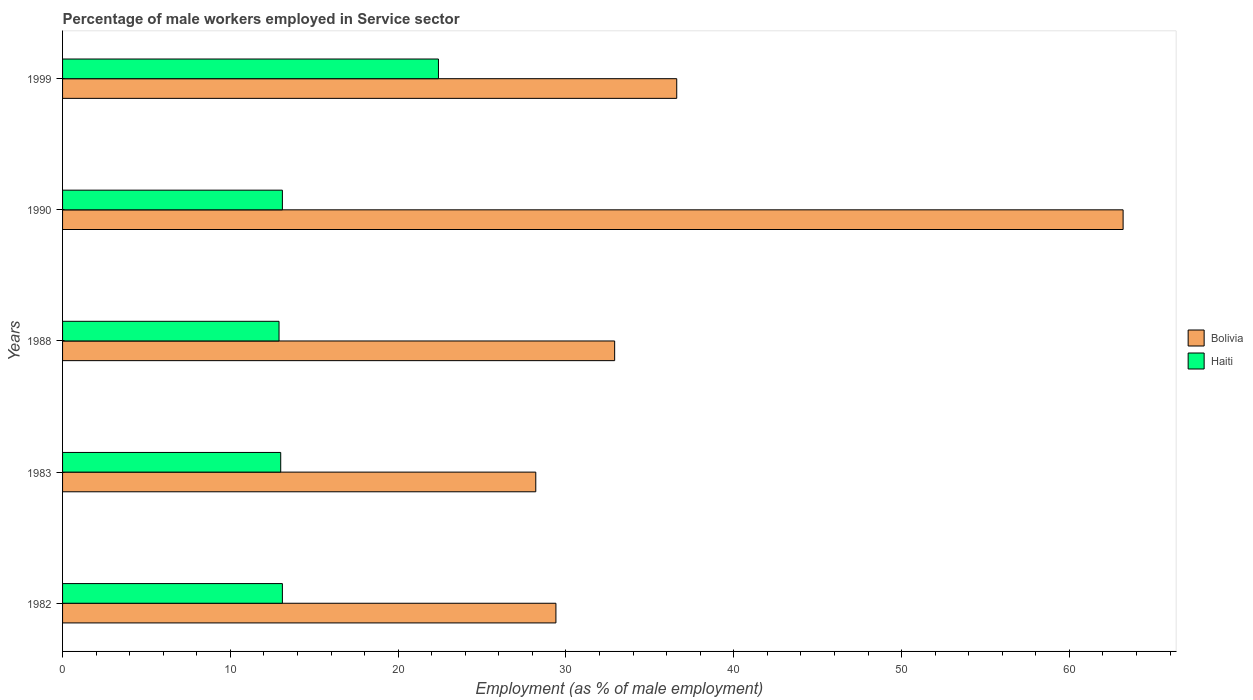How many groups of bars are there?
Keep it short and to the point. 5. Are the number of bars per tick equal to the number of legend labels?
Your response must be concise. Yes. Are the number of bars on each tick of the Y-axis equal?
Offer a very short reply. Yes. How many bars are there on the 2nd tick from the top?
Provide a succinct answer. 2. How many bars are there on the 4th tick from the bottom?
Ensure brevity in your answer.  2. What is the label of the 4th group of bars from the top?
Offer a very short reply. 1983. What is the percentage of male workers employed in Service sector in Haiti in 1988?
Give a very brief answer. 12.9. Across all years, what is the maximum percentage of male workers employed in Service sector in Bolivia?
Make the answer very short. 63.2. Across all years, what is the minimum percentage of male workers employed in Service sector in Bolivia?
Provide a succinct answer. 28.2. In which year was the percentage of male workers employed in Service sector in Bolivia maximum?
Provide a short and direct response. 1990. What is the total percentage of male workers employed in Service sector in Haiti in the graph?
Provide a short and direct response. 74.5. What is the difference between the percentage of male workers employed in Service sector in Haiti in 1990 and that in 1999?
Make the answer very short. -9.3. What is the difference between the percentage of male workers employed in Service sector in Bolivia in 1988 and the percentage of male workers employed in Service sector in Haiti in 1982?
Your answer should be compact. 19.8. In the year 1988, what is the difference between the percentage of male workers employed in Service sector in Bolivia and percentage of male workers employed in Service sector in Haiti?
Give a very brief answer. 20. In how many years, is the percentage of male workers employed in Service sector in Bolivia greater than 20 %?
Your answer should be compact. 5. What is the ratio of the percentage of male workers employed in Service sector in Haiti in 1988 to that in 1999?
Keep it short and to the point. 0.58. Is the difference between the percentage of male workers employed in Service sector in Bolivia in 1982 and 1999 greater than the difference between the percentage of male workers employed in Service sector in Haiti in 1982 and 1999?
Provide a short and direct response. Yes. What is the difference between the highest and the second highest percentage of male workers employed in Service sector in Bolivia?
Ensure brevity in your answer.  26.6. What is the difference between the highest and the lowest percentage of male workers employed in Service sector in Haiti?
Provide a short and direct response. 9.5. In how many years, is the percentage of male workers employed in Service sector in Bolivia greater than the average percentage of male workers employed in Service sector in Bolivia taken over all years?
Your response must be concise. 1. Is the sum of the percentage of male workers employed in Service sector in Bolivia in 1982 and 1983 greater than the maximum percentage of male workers employed in Service sector in Haiti across all years?
Ensure brevity in your answer.  Yes. What does the 1st bar from the top in 1982 represents?
Ensure brevity in your answer.  Haiti. What does the 1st bar from the bottom in 1982 represents?
Keep it short and to the point. Bolivia. Are all the bars in the graph horizontal?
Provide a succinct answer. Yes. How many years are there in the graph?
Provide a short and direct response. 5. Does the graph contain any zero values?
Your answer should be very brief. No. Where does the legend appear in the graph?
Your response must be concise. Center right. How are the legend labels stacked?
Provide a short and direct response. Vertical. What is the title of the graph?
Your answer should be very brief. Percentage of male workers employed in Service sector. Does "Swaziland" appear as one of the legend labels in the graph?
Offer a very short reply. No. What is the label or title of the X-axis?
Offer a very short reply. Employment (as % of male employment). What is the Employment (as % of male employment) of Bolivia in 1982?
Give a very brief answer. 29.4. What is the Employment (as % of male employment) in Haiti in 1982?
Keep it short and to the point. 13.1. What is the Employment (as % of male employment) in Bolivia in 1983?
Provide a succinct answer. 28.2. What is the Employment (as % of male employment) of Bolivia in 1988?
Your answer should be compact. 32.9. What is the Employment (as % of male employment) of Haiti in 1988?
Keep it short and to the point. 12.9. What is the Employment (as % of male employment) in Bolivia in 1990?
Your response must be concise. 63.2. What is the Employment (as % of male employment) in Haiti in 1990?
Provide a short and direct response. 13.1. What is the Employment (as % of male employment) in Bolivia in 1999?
Your answer should be compact. 36.6. What is the Employment (as % of male employment) in Haiti in 1999?
Offer a very short reply. 22.4. Across all years, what is the maximum Employment (as % of male employment) of Bolivia?
Offer a terse response. 63.2. Across all years, what is the maximum Employment (as % of male employment) in Haiti?
Offer a very short reply. 22.4. Across all years, what is the minimum Employment (as % of male employment) in Bolivia?
Your answer should be very brief. 28.2. Across all years, what is the minimum Employment (as % of male employment) in Haiti?
Your answer should be very brief. 12.9. What is the total Employment (as % of male employment) in Bolivia in the graph?
Keep it short and to the point. 190.3. What is the total Employment (as % of male employment) in Haiti in the graph?
Your answer should be compact. 74.5. What is the difference between the Employment (as % of male employment) of Haiti in 1982 and that in 1983?
Ensure brevity in your answer.  0.1. What is the difference between the Employment (as % of male employment) of Bolivia in 1982 and that in 1988?
Your response must be concise. -3.5. What is the difference between the Employment (as % of male employment) of Bolivia in 1982 and that in 1990?
Provide a short and direct response. -33.8. What is the difference between the Employment (as % of male employment) of Haiti in 1982 and that in 1990?
Provide a succinct answer. 0. What is the difference between the Employment (as % of male employment) in Bolivia in 1983 and that in 1990?
Offer a terse response. -35. What is the difference between the Employment (as % of male employment) of Haiti in 1983 and that in 1990?
Give a very brief answer. -0.1. What is the difference between the Employment (as % of male employment) of Haiti in 1983 and that in 1999?
Make the answer very short. -9.4. What is the difference between the Employment (as % of male employment) of Bolivia in 1988 and that in 1990?
Make the answer very short. -30.3. What is the difference between the Employment (as % of male employment) of Haiti in 1988 and that in 1990?
Your response must be concise. -0.2. What is the difference between the Employment (as % of male employment) of Haiti in 1988 and that in 1999?
Your response must be concise. -9.5. What is the difference between the Employment (as % of male employment) of Bolivia in 1990 and that in 1999?
Make the answer very short. 26.6. What is the difference between the Employment (as % of male employment) in Bolivia in 1982 and the Employment (as % of male employment) in Haiti in 1990?
Provide a short and direct response. 16.3. What is the difference between the Employment (as % of male employment) of Bolivia in 1983 and the Employment (as % of male employment) of Haiti in 1990?
Provide a succinct answer. 15.1. What is the difference between the Employment (as % of male employment) in Bolivia in 1988 and the Employment (as % of male employment) in Haiti in 1990?
Provide a succinct answer. 19.8. What is the difference between the Employment (as % of male employment) of Bolivia in 1990 and the Employment (as % of male employment) of Haiti in 1999?
Your response must be concise. 40.8. What is the average Employment (as % of male employment) of Bolivia per year?
Your answer should be compact. 38.06. In the year 1983, what is the difference between the Employment (as % of male employment) of Bolivia and Employment (as % of male employment) of Haiti?
Your answer should be compact. 15.2. In the year 1990, what is the difference between the Employment (as % of male employment) of Bolivia and Employment (as % of male employment) of Haiti?
Your answer should be compact. 50.1. What is the ratio of the Employment (as % of male employment) in Bolivia in 1982 to that in 1983?
Keep it short and to the point. 1.04. What is the ratio of the Employment (as % of male employment) in Haiti in 1982 to that in 1983?
Your answer should be compact. 1.01. What is the ratio of the Employment (as % of male employment) in Bolivia in 1982 to that in 1988?
Your answer should be compact. 0.89. What is the ratio of the Employment (as % of male employment) of Haiti in 1982 to that in 1988?
Your response must be concise. 1.02. What is the ratio of the Employment (as % of male employment) in Bolivia in 1982 to that in 1990?
Ensure brevity in your answer.  0.47. What is the ratio of the Employment (as % of male employment) in Bolivia in 1982 to that in 1999?
Provide a short and direct response. 0.8. What is the ratio of the Employment (as % of male employment) of Haiti in 1982 to that in 1999?
Your response must be concise. 0.58. What is the ratio of the Employment (as % of male employment) in Haiti in 1983 to that in 1988?
Your response must be concise. 1.01. What is the ratio of the Employment (as % of male employment) of Bolivia in 1983 to that in 1990?
Your answer should be compact. 0.45. What is the ratio of the Employment (as % of male employment) in Haiti in 1983 to that in 1990?
Keep it short and to the point. 0.99. What is the ratio of the Employment (as % of male employment) in Bolivia in 1983 to that in 1999?
Keep it short and to the point. 0.77. What is the ratio of the Employment (as % of male employment) of Haiti in 1983 to that in 1999?
Give a very brief answer. 0.58. What is the ratio of the Employment (as % of male employment) in Bolivia in 1988 to that in 1990?
Offer a very short reply. 0.52. What is the ratio of the Employment (as % of male employment) in Haiti in 1988 to that in 1990?
Provide a succinct answer. 0.98. What is the ratio of the Employment (as % of male employment) in Bolivia in 1988 to that in 1999?
Make the answer very short. 0.9. What is the ratio of the Employment (as % of male employment) in Haiti in 1988 to that in 1999?
Give a very brief answer. 0.58. What is the ratio of the Employment (as % of male employment) of Bolivia in 1990 to that in 1999?
Offer a terse response. 1.73. What is the ratio of the Employment (as % of male employment) in Haiti in 1990 to that in 1999?
Give a very brief answer. 0.58. What is the difference between the highest and the second highest Employment (as % of male employment) of Bolivia?
Your answer should be compact. 26.6. What is the difference between the highest and the second highest Employment (as % of male employment) in Haiti?
Your answer should be compact. 9.3. What is the difference between the highest and the lowest Employment (as % of male employment) in Haiti?
Offer a terse response. 9.5. 